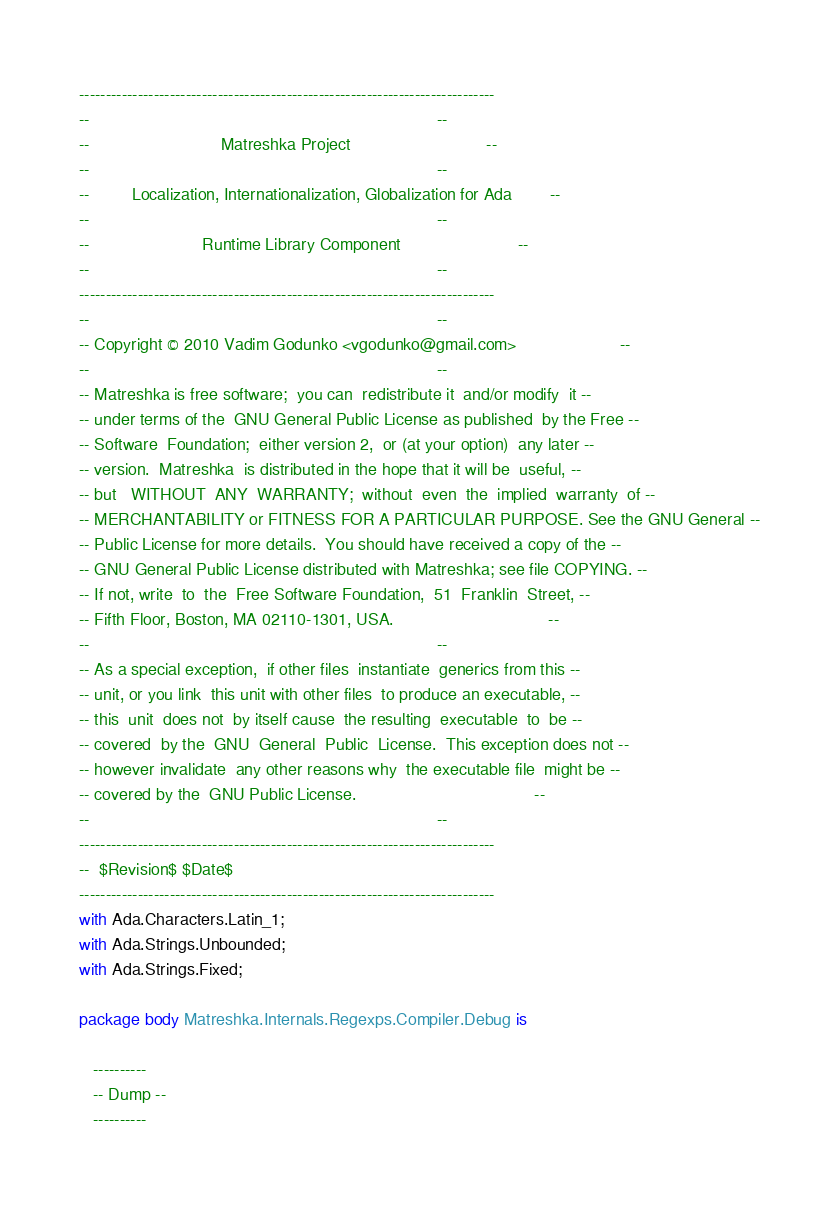Convert code to text. <code><loc_0><loc_0><loc_500><loc_500><_Ada_>------------------------------------------------------------------------------
--                                                                          --
--                            Matreshka Project                             --
--                                                                          --
--         Localization, Internationalization, Globalization for Ada        --
--                                                                          --
--                        Runtime Library Component                         --
--                                                                          --
------------------------------------------------------------------------------
--                                                                          --
-- Copyright © 2010 Vadim Godunko <vgodunko@gmail.com>                      --
--                                                                          --
-- Matreshka is free software;  you can  redistribute it  and/or modify  it --
-- under terms of the  GNU General Public License as published  by the Free --
-- Software  Foundation;  either version 2,  or (at your option)  any later --
-- version.  Matreshka  is distributed in the hope that it will be  useful, --
-- but   WITHOUT  ANY  WARRANTY;  without  even  the  implied  warranty  of --
-- MERCHANTABILITY or FITNESS FOR A PARTICULAR PURPOSE. See the GNU General --
-- Public License for more details.  You should have received a copy of the --
-- GNU General Public License distributed with Matreshka; see file COPYING. --
-- If not, write  to  the  Free Software Foundation,  51  Franklin  Street, --
-- Fifth Floor, Boston, MA 02110-1301, USA.                                 --
--                                                                          --
-- As a special exception,  if other files  instantiate  generics from this --
-- unit, or you link  this unit with other files  to produce an executable, --
-- this  unit  does not  by itself cause  the resulting  executable  to  be --
-- covered  by the  GNU  General  Public  License.  This exception does not --
-- however invalidate  any other reasons why  the executable file  might be --
-- covered by the  GNU Public License.                                      --
--                                                                          --
------------------------------------------------------------------------------
--  $Revision$ $Date$
------------------------------------------------------------------------------
with Ada.Characters.Latin_1;
with Ada.Strings.Unbounded;
with Ada.Strings.Fixed;

package body Matreshka.Internals.Regexps.Compiler.Debug is

   ----------
   -- Dump --
   ----------
</code> 